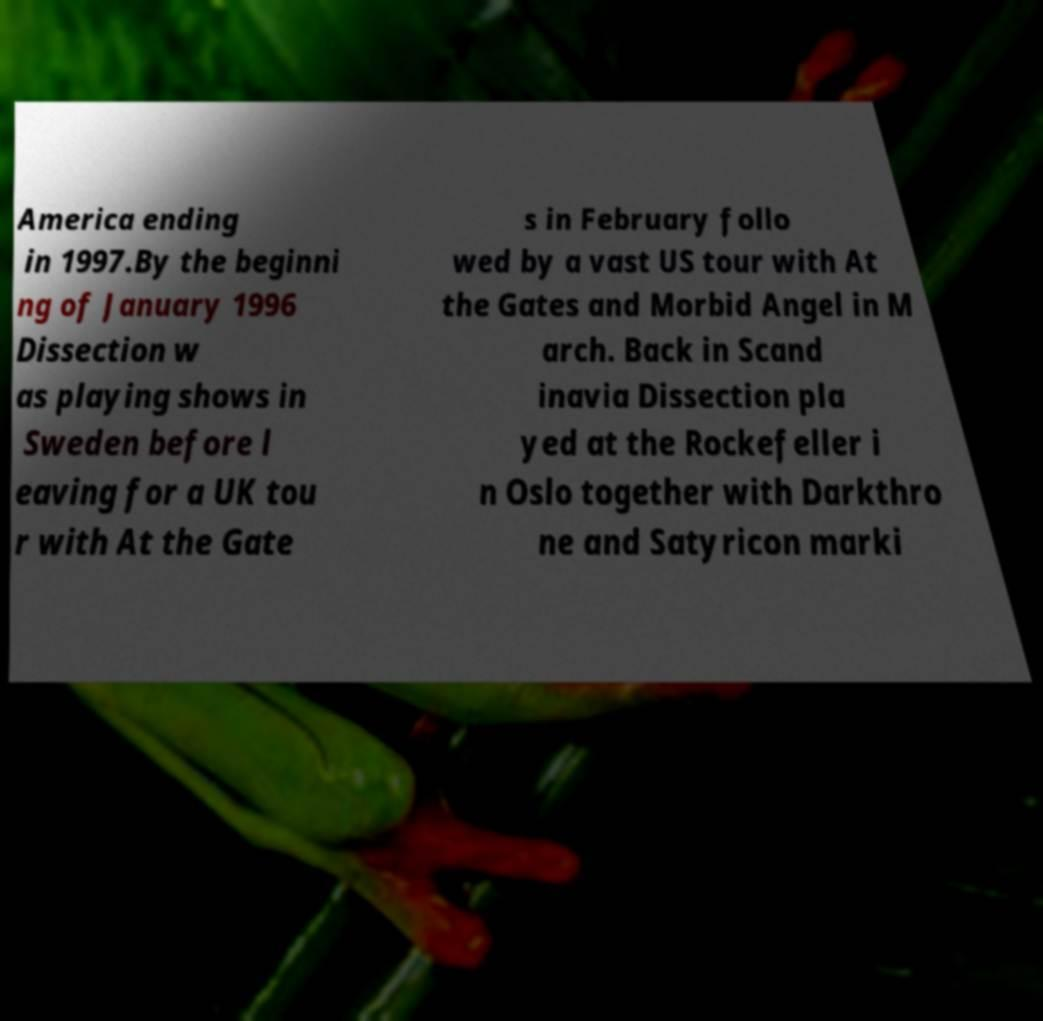I need the written content from this picture converted into text. Can you do that? America ending in 1997.By the beginni ng of January 1996 Dissection w as playing shows in Sweden before l eaving for a UK tou r with At the Gate s in February follo wed by a vast US tour with At the Gates and Morbid Angel in M arch. Back in Scand inavia Dissection pla yed at the Rockefeller i n Oslo together with Darkthro ne and Satyricon marki 